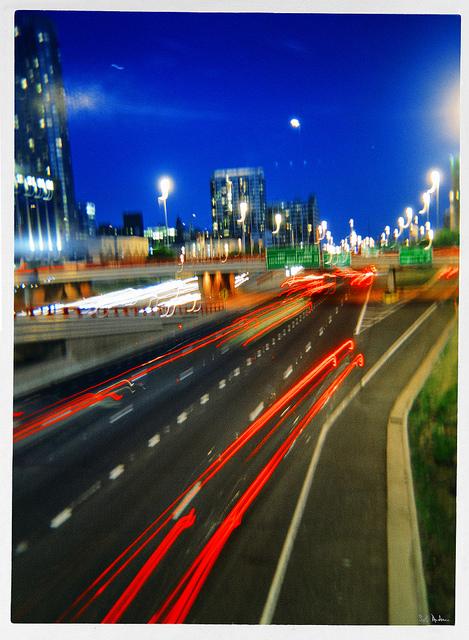What is blue in this photo?
Quick response, please. Sky. What is causing the lights?
Answer briefly. Cars. Is the exposure time too long?
Keep it brief. Yes. 